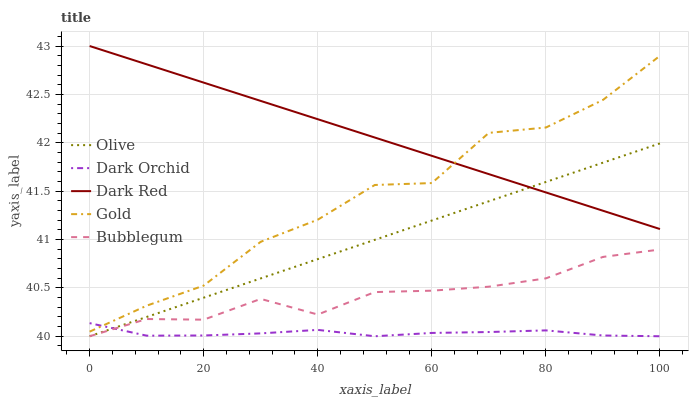Does Dark Orchid have the minimum area under the curve?
Answer yes or no. Yes. Does Dark Red have the maximum area under the curve?
Answer yes or no. Yes. Does Bubblegum have the minimum area under the curve?
Answer yes or no. No. Does Bubblegum have the maximum area under the curve?
Answer yes or no. No. Is Olive the smoothest?
Answer yes or no. Yes. Is Gold the roughest?
Answer yes or no. Yes. Is Bubblegum the smoothest?
Answer yes or no. No. Is Bubblegum the roughest?
Answer yes or no. No. Does Olive have the lowest value?
Answer yes or no. Yes. Does Dark Red have the lowest value?
Answer yes or no. No. Does Dark Red have the highest value?
Answer yes or no. Yes. Does Bubblegum have the highest value?
Answer yes or no. No. Is Bubblegum less than Gold?
Answer yes or no. Yes. Is Gold greater than Olive?
Answer yes or no. Yes. Does Olive intersect Dark Orchid?
Answer yes or no. Yes. Is Olive less than Dark Orchid?
Answer yes or no. No. Is Olive greater than Dark Orchid?
Answer yes or no. No. Does Bubblegum intersect Gold?
Answer yes or no. No. 